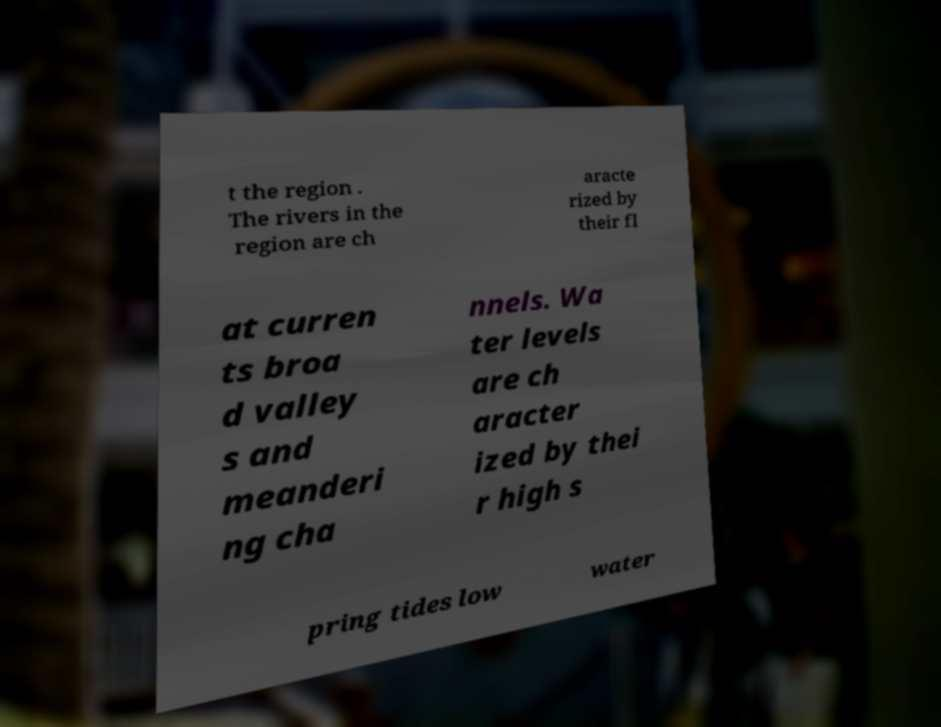Can you read and provide the text displayed in the image?This photo seems to have some interesting text. Can you extract and type it out for me? t the region . The rivers in the region are ch aracte rized by their fl at curren ts broa d valley s and meanderi ng cha nnels. Wa ter levels are ch aracter ized by thei r high s pring tides low water 